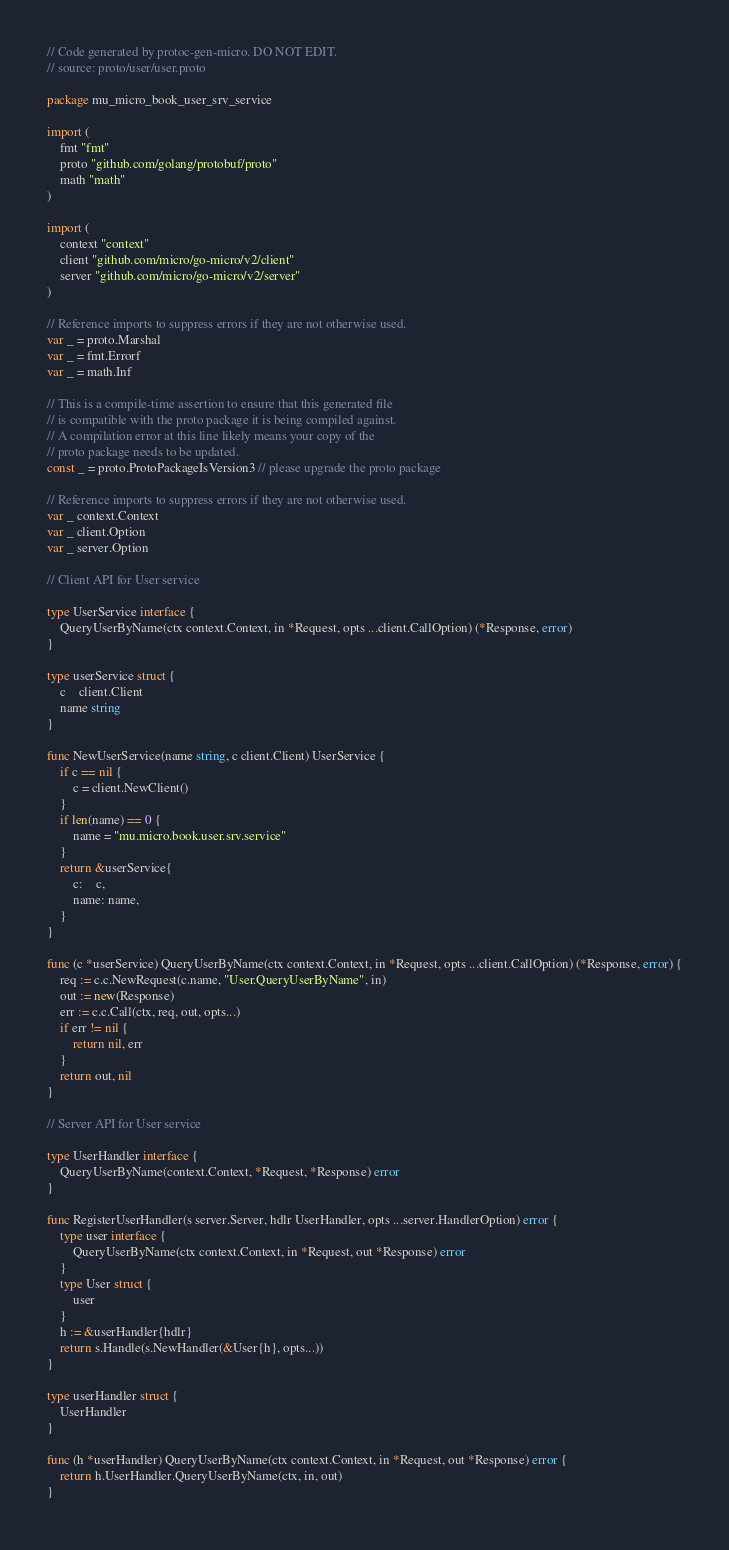Convert code to text. <code><loc_0><loc_0><loc_500><loc_500><_Go_>// Code generated by protoc-gen-micro. DO NOT EDIT.
// source: proto/user/user.proto

package mu_micro_book_user_srv_service

import (
	fmt "fmt"
	proto "github.com/golang/protobuf/proto"
	math "math"
)

import (
	context "context"
	client "github.com/micro/go-micro/v2/client"
	server "github.com/micro/go-micro/v2/server"
)

// Reference imports to suppress errors if they are not otherwise used.
var _ = proto.Marshal
var _ = fmt.Errorf
var _ = math.Inf

// This is a compile-time assertion to ensure that this generated file
// is compatible with the proto package it is being compiled against.
// A compilation error at this line likely means your copy of the
// proto package needs to be updated.
const _ = proto.ProtoPackageIsVersion3 // please upgrade the proto package

// Reference imports to suppress errors if they are not otherwise used.
var _ context.Context
var _ client.Option
var _ server.Option

// Client API for User service

type UserService interface {
	QueryUserByName(ctx context.Context, in *Request, opts ...client.CallOption) (*Response, error)
}

type userService struct {
	c    client.Client
	name string
}

func NewUserService(name string, c client.Client) UserService {
	if c == nil {
		c = client.NewClient()
	}
	if len(name) == 0 {
		name = "mu.micro.book.user.srv.service"
	}
	return &userService{
		c:    c,
		name: name,
	}
}

func (c *userService) QueryUserByName(ctx context.Context, in *Request, opts ...client.CallOption) (*Response, error) {
	req := c.c.NewRequest(c.name, "User.QueryUserByName", in)
	out := new(Response)
	err := c.c.Call(ctx, req, out, opts...)
	if err != nil {
		return nil, err
	}
	return out, nil
}

// Server API for User service

type UserHandler interface {
	QueryUserByName(context.Context, *Request, *Response) error
}

func RegisterUserHandler(s server.Server, hdlr UserHandler, opts ...server.HandlerOption) error {
	type user interface {
		QueryUserByName(ctx context.Context, in *Request, out *Response) error
	}
	type User struct {
		user
	}
	h := &userHandler{hdlr}
	return s.Handle(s.NewHandler(&User{h}, opts...))
}

type userHandler struct {
	UserHandler
}

func (h *userHandler) QueryUserByName(ctx context.Context, in *Request, out *Response) error {
	return h.UserHandler.QueryUserByName(ctx, in, out)
}
</code> 